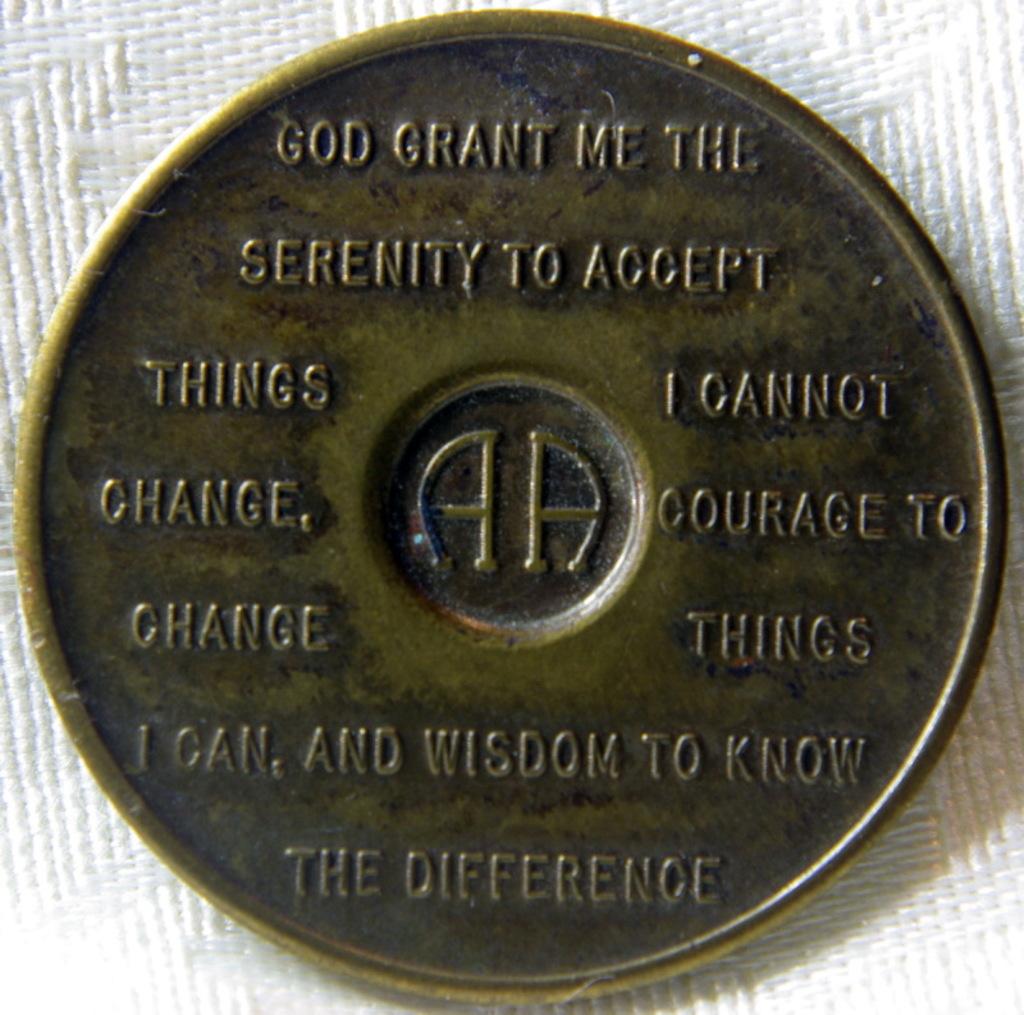What does ability does wisdom give?
Your answer should be compact. To know the difference. Who grant me serenity?
Keep it short and to the point. God. 